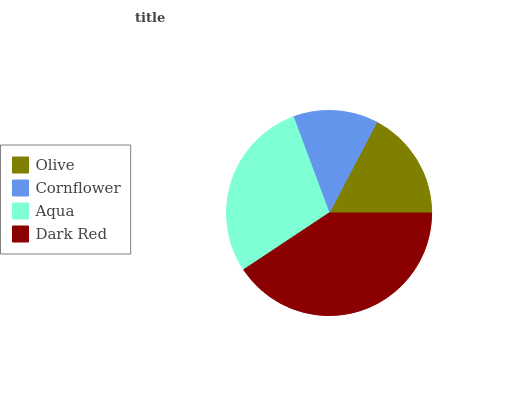Is Cornflower the minimum?
Answer yes or no. Yes. Is Dark Red the maximum?
Answer yes or no. Yes. Is Aqua the minimum?
Answer yes or no. No. Is Aqua the maximum?
Answer yes or no. No. Is Aqua greater than Cornflower?
Answer yes or no. Yes. Is Cornflower less than Aqua?
Answer yes or no. Yes. Is Cornflower greater than Aqua?
Answer yes or no. No. Is Aqua less than Cornflower?
Answer yes or no. No. Is Aqua the high median?
Answer yes or no. Yes. Is Olive the low median?
Answer yes or no. Yes. Is Dark Red the high median?
Answer yes or no. No. Is Dark Red the low median?
Answer yes or no. No. 